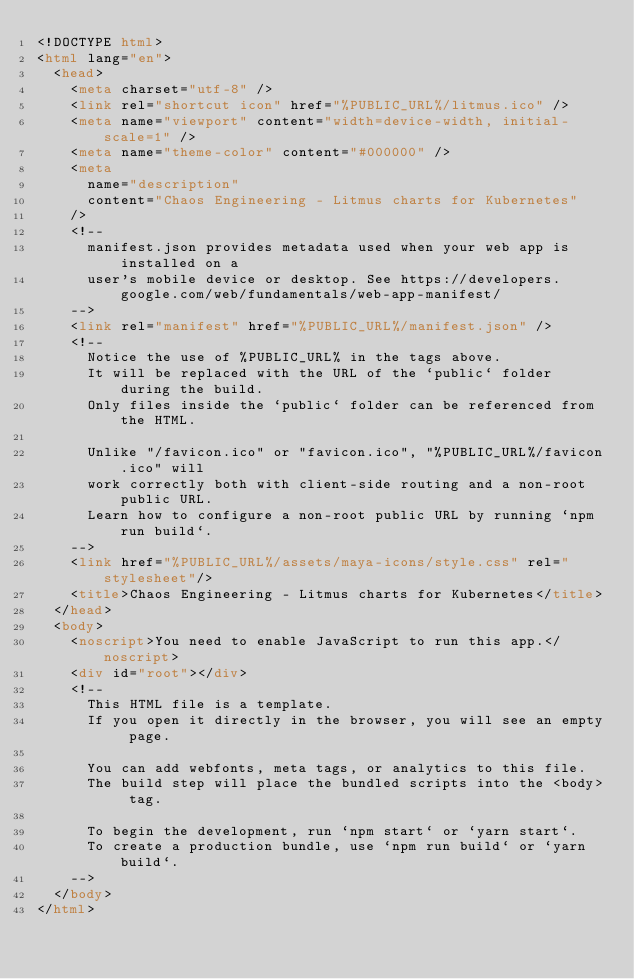<code> <loc_0><loc_0><loc_500><loc_500><_HTML_><!DOCTYPE html>
<html lang="en">
  <head>
    <meta charset="utf-8" />
    <link rel="shortcut icon" href="%PUBLIC_URL%/litmus.ico" />
    <meta name="viewport" content="width=device-width, initial-scale=1" />
    <meta name="theme-color" content="#000000" />
    <meta
      name="description"
      content="Chaos Engineering - Litmus charts for Kubernetes"
    />
    <!--
      manifest.json provides metadata used when your web app is installed on a
      user's mobile device or desktop. See https://developers.google.com/web/fundamentals/web-app-manifest/
    -->
    <link rel="manifest" href="%PUBLIC_URL%/manifest.json" />
    <!--
      Notice the use of %PUBLIC_URL% in the tags above.
      It will be replaced with the URL of the `public` folder during the build.
      Only files inside the `public` folder can be referenced from the HTML.

      Unlike "/favicon.ico" or "favicon.ico", "%PUBLIC_URL%/favicon.ico" will
      work correctly both with client-side routing and a non-root public URL.
      Learn how to configure a non-root public URL by running `npm run build`.
    -->
    <link href="%PUBLIC_URL%/assets/maya-icons/style.css" rel="stylesheet"/>
    <title>Chaos Engineering - Litmus charts for Kubernetes</title>
  </head>
  <body>
    <noscript>You need to enable JavaScript to run this app.</noscript>
    <div id="root"></div>
    <!--
      This HTML file is a template.
      If you open it directly in the browser, you will see an empty page.

      You can add webfonts, meta tags, or analytics to this file.
      The build step will place the bundled scripts into the <body> tag.

      To begin the development, run `npm start` or `yarn start`.
      To create a production bundle, use `npm run build` or `yarn build`.
    -->
  </body>
</html>
</code> 